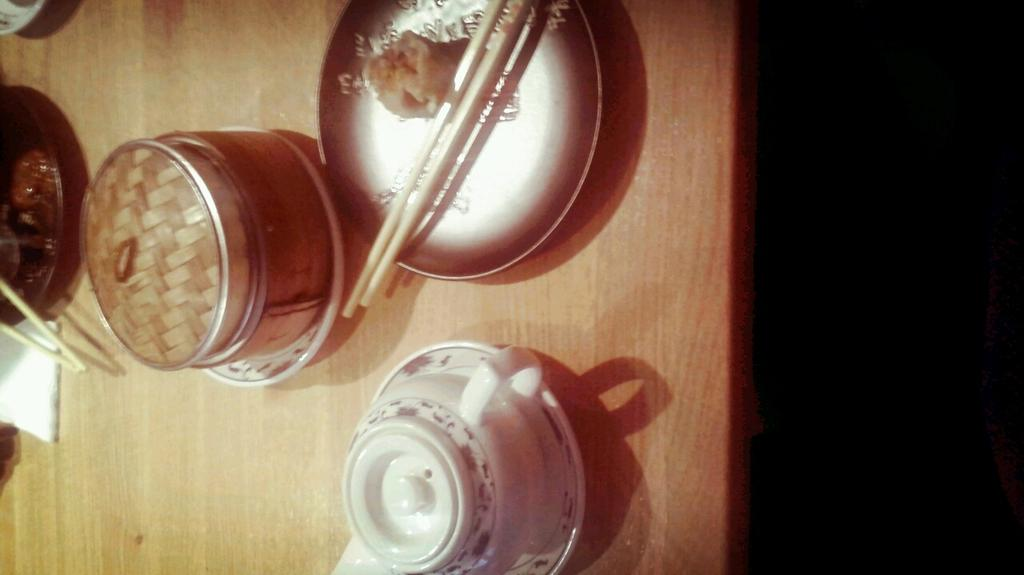What piece of furniture is visible in the image? There is a table in the image. What object can be seen on the table? There is a jar on the table. What type of food items are on the table? There is a plate with food items on the table. What utensils are present on the table? Chopsticks are present on the table. What type of dishware is on the table? There is a cup with a saucer on the table. What letter is written on the plate in the image? There is no letter written on the plate in the image; it contains food items. 